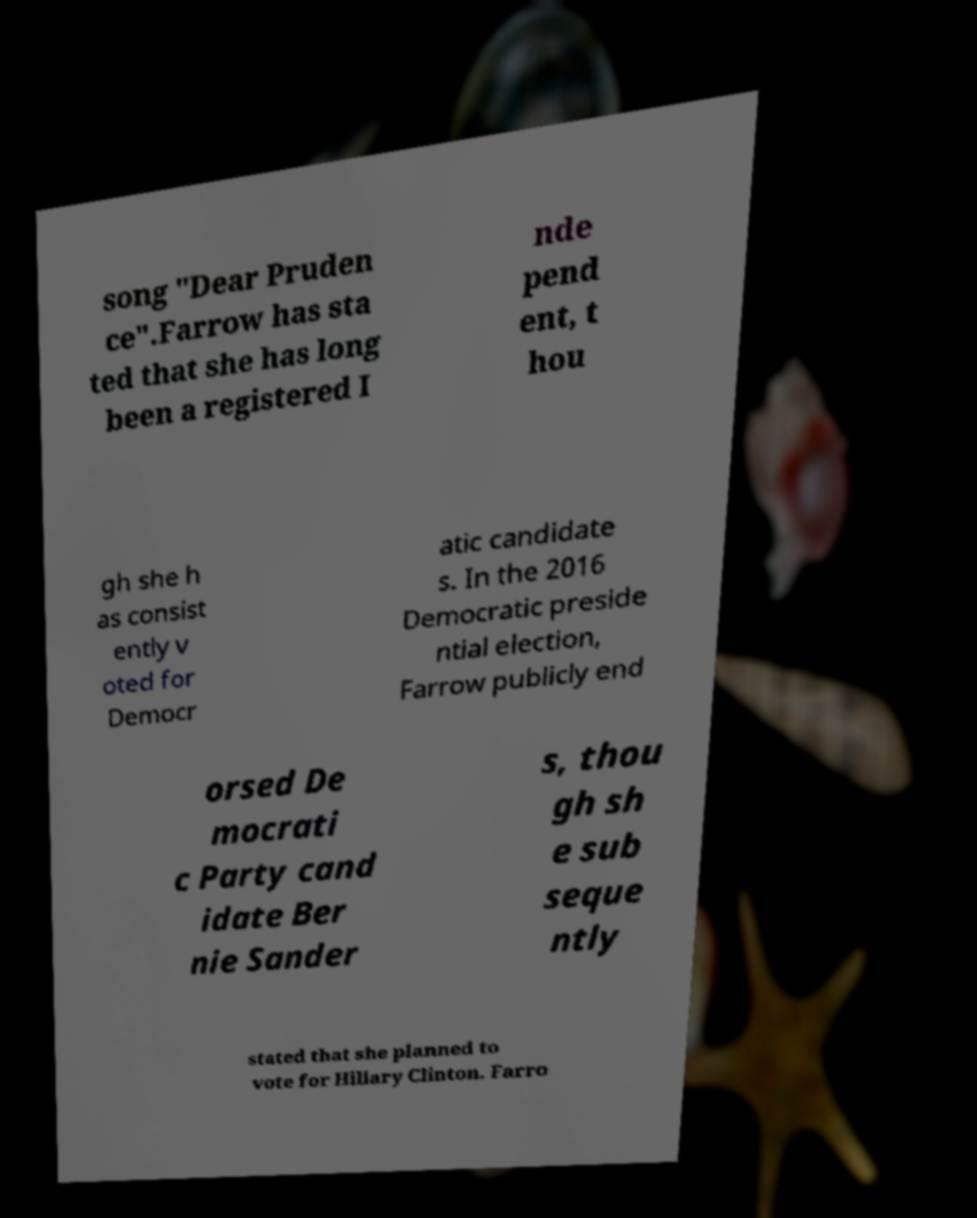I need the written content from this picture converted into text. Can you do that? song "Dear Pruden ce".Farrow has sta ted that she has long been a registered I nde pend ent, t hou gh she h as consist ently v oted for Democr atic candidate s. In the 2016 Democratic preside ntial election, Farrow publicly end orsed De mocrati c Party cand idate Ber nie Sander s, thou gh sh e sub seque ntly stated that she planned to vote for Hillary Clinton. Farro 